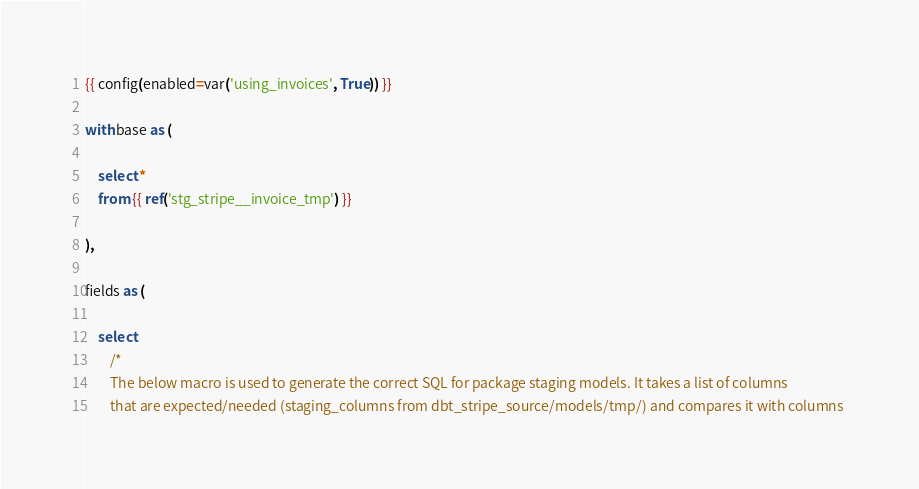<code> <loc_0><loc_0><loc_500><loc_500><_SQL_>{{ config(enabled=var('using_invoices', True)) }}

with base as (

    select * 
    from {{ ref('stg_stripe__invoice_tmp') }}

),

fields as (

    select
        /*
        The below macro is used to generate the correct SQL for package staging models. It takes a list of columns 
        that are expected/needed (staging_columns from dbt_stripe_source/models/tmp/) and compares it with columns </code> 